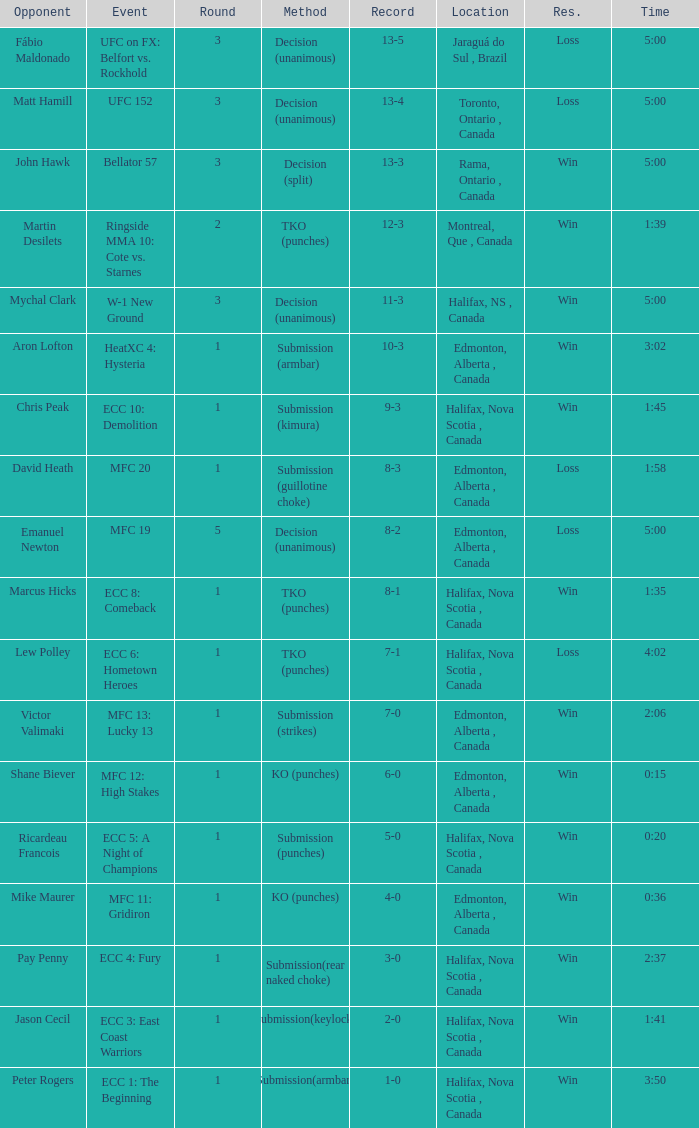Who is the opponent of the match with a win result and a time of 3:02? Aron Lofton. 